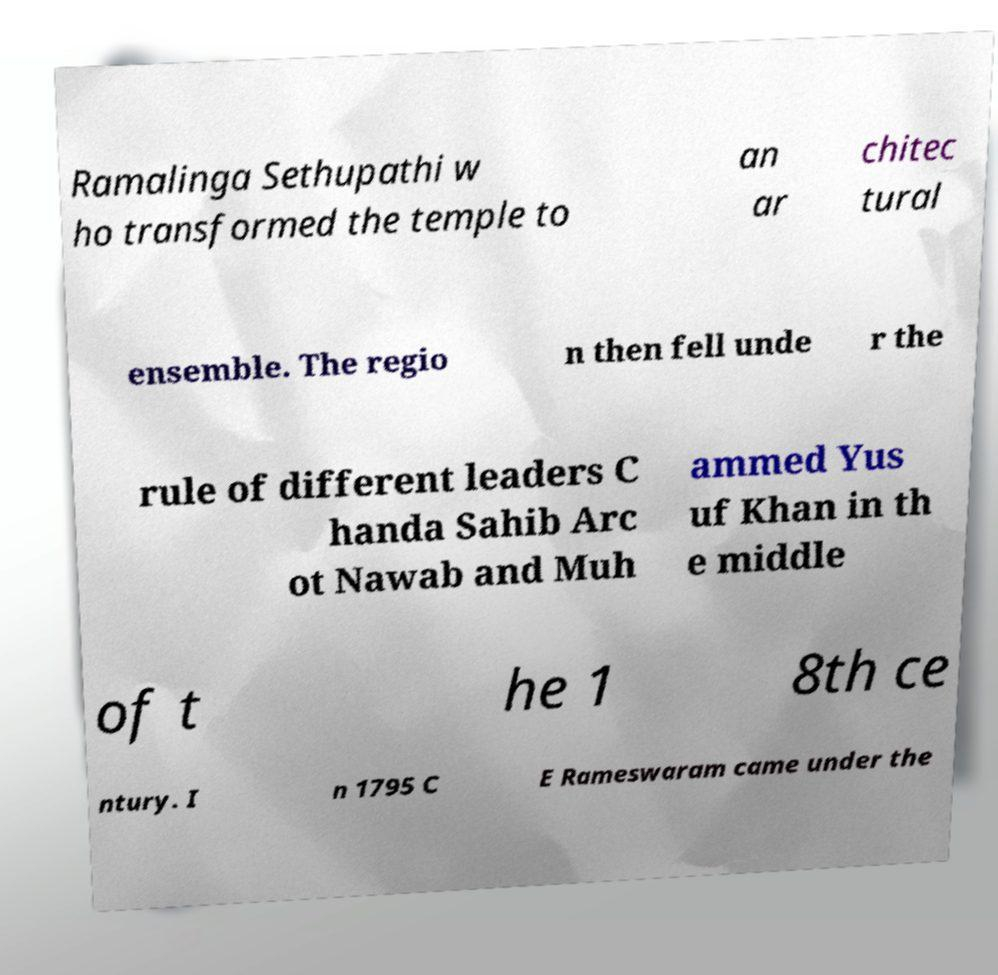There's text embedded in this image that I need extracted. Can you transcribe it verbatim? Ramalinga Sethupathi w ho transformed the temple to an ar chitec tural ensemble. The regio n then fell unde r the rule of different leaders C handa Sahib Arc ot Nawab and Muh ammed Yus uf Khan in th e middle of t he 1 8th ce ntury. I n 1795 C E Rameswaram came under the 